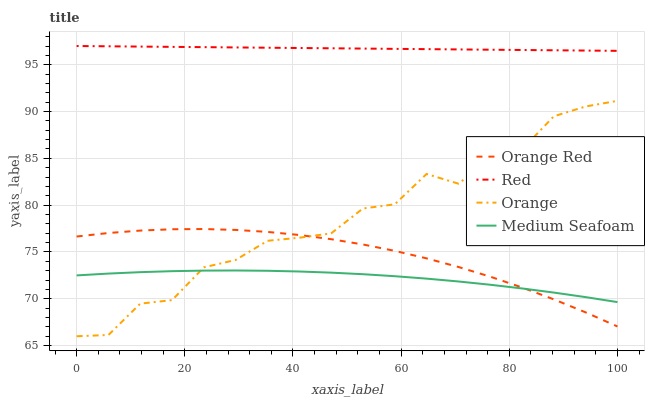Does Medium Seafoam have the minimum area under the curve?
Answer yes or no. Yes. Does Red have the maximum area under the curve?
Answer yes or no. Yes. Does Orange Red have the minimum area under the curve?
Answer yes or no. No. Does Orange Red have the maximum area under the curve?
Answer yes or no. No. Is Red the smoothest?
Answer yes or no. Yes. Is Orange the roughest?
Answer yes or no. Yes. Is Orange Red the smoothest?
Answer yes or no. No. Is Orange Red the roughest?
Answer yes or no. No. Does Orange have the lowest value?
Answer yes or no. Yes. Does Orange Red have the lowest value?
Answer yes or no. No. Does Red have the highest value?
Answer yes or no. Yes. Does Orange Red have the highest value?
Answer yes or no. No. Is Medium Seafoam less than Red?
Answer yes or no. Yes. Is Red greater than Medium Seafoam?
Answer yes or no. Yes. Does Orange intersect Medium Seafoam?
Answer yes or no. Yes. Is Orange less than Medium Seafoam?
Answer yes or no. No. Is Orange greater than Medium Seafoam?
Answer yes or no. No. Does Medium Seafoam intersect Red?
Answer yes or no. No. 